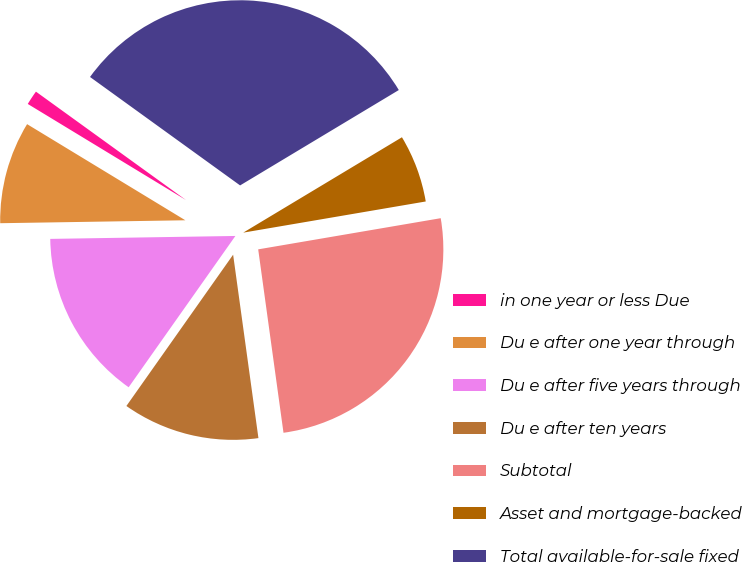Convert chart. <chart><loc_0><loc_0><loc_500><loc_500><pie_chart><fcel>in one year or less Due<fcel>Du e after one year through<fcel>Du e after five years through<fcel>Du e after ten years<fcel>Subtotal<fcel>Asset and mortgage-backed<fcel>Total available-for-sale fixed<nl><fcel>1.27%<fcel>8.94%<fcel>14.97%<fcel>11.96%<fcel>25.51%<fcel>5.92%<fcel>31.43%<nl></chart> 